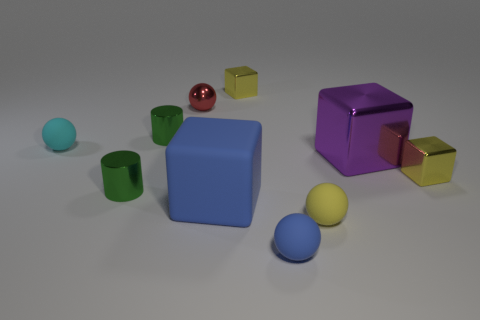How many objects are small shiny objects that are right of the blue matte sphere or large metal spheres?
Offer a very short reply. 1. There is a shiny sphere that is the same size as the yellow matte sphere; what is its color?
Offer a very short reply. Red. Are there more large matte objects to the left of the large blue rubber thing than red things?
Offer a very short reply. No. There is a tiny yellow object that is in front of the purple cube and on the left side of the large purple shiny thing; what is it made of?
Your answer should be compact. Rubber. Do the large cube behind the large blue matte block and the tiny block that is behind the cyan matte ball have the same color?
Offer a very short reply. No. How many other objects are there of the same size as the metal sphere?
Your response must be concise. 7. There is a tiny cylinder behind the metallic cylinder in front of the tiny cyan ball; is there a cyan rubber ball right of it?
Provide a short and direct response. No. Do the big block that is to the right of the tiny blue thing and the small red thing have the same material?
Give a very brief answer. Yes. The other shiny object that is the same shape as the tiny cyan object is what color?
Keep it short and to the point. Red. Are there any other things that have the same shape as the purple metal thing?
Keep it short and to the point. Yes. 